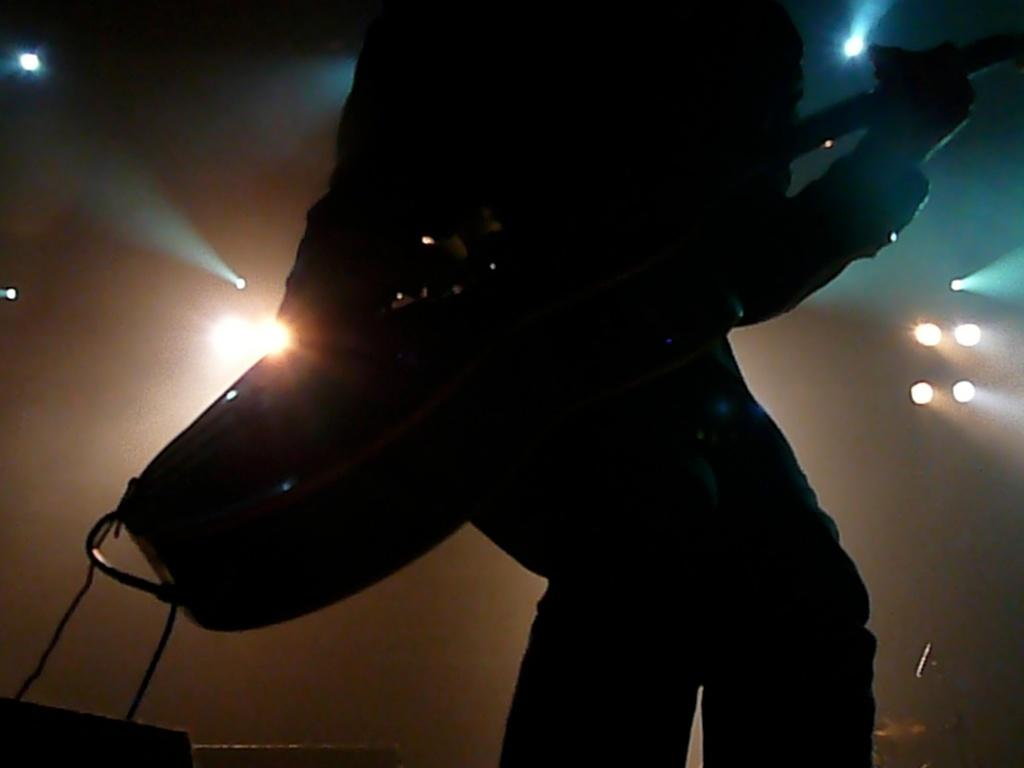What is the person in the image doing? The person in the image is playing a guitar. Can you describe the lighting situation in the image? There are many lights present in the image. Can you tell me how many dogs are visible in the image? There are no dogs present in the image. What type of throat condition does the person in the image have? There is no information about the person's throat condition in the image. 